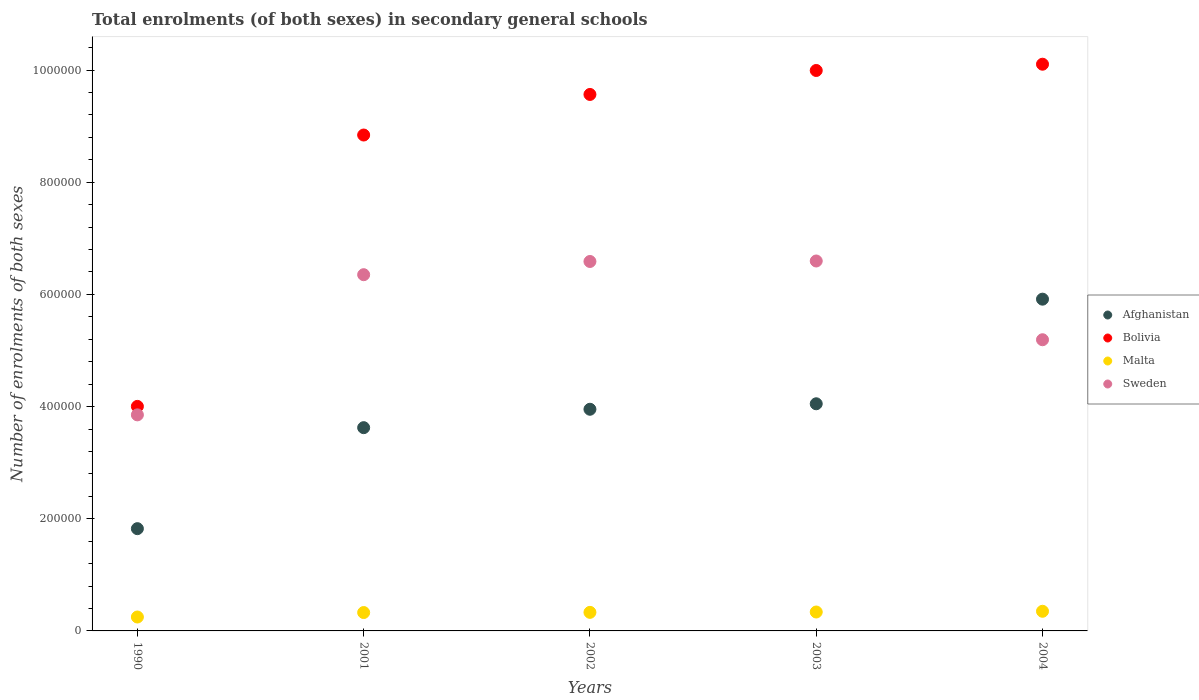Is the number of dotlines equal to the number of legend labels?
Your answer should be compact. Yes. What is the number of enrolments in secondary schools in Malta in 2001?
Your answer should be compact. 3.28e+04. Across all years, what is the maximum number of enrolments in secondary schools in Afghanistan?
Provide a short and direct response. 5.92e+05. Across all years, what is the minimum number of enrolments in secondary schools in Sweden?
Make the answer very short. 3.85e+05. In which year was the number of enrolments in secondary schools in Malta maximum?
Provide a succinct answer. 2004. What is the total number of enrolments in secondary schools in Bolivia in the graph?
Keep it short and to the point. 4.25e+06. What is the difference between the number of enrolments in secondary schools in Sweden in 1990 and that in 2003?
Keep it short and to the point. -2.74e+05. What is the difference between the number of enrolments in secondary schools in Malta in 2002 and the number of enrolments in secondary schools in Bolivia in 2003?
Keep it short and to the point. -9.66e+05. What is the average number of enrolments in secondary schools in Afghanistan per year?
Provide a succinct answer. 3.87e+05. In the year 2002, what is the difference between the number of enrolments in secondary schools in Bolivia and number of enrolments in secondary schools in Afghanistan?
Give a very brief answer. 5.61e+05. What is the ratio of the number of enrolments in secondary schools in Malta in 1990 to that in 2002?
Provide a succinct answer. 0.75. Is the difference between the number of enrolments in secondary schools in Bolivia in 1990 and 2001 greater than the difference between the number of enrolments in secondary schools in Afghanistan in 1990 and 2001?
Keep it short and to the point. No. What is the difference between the highest and the second highest number of enrolments in secondary schools in Sweden?
Your answer should be compact. 878. What is the difference between the highest and the lowest number of enrolments in secondary schools in Sweden?
Give a very brief answer. 2.74e+05. In how many years, is the number of enrolments in secondary schools in Afghanistan greater than the average number of enrolments in secondary schools in Afghanistan taken over all years?
Your response must be concise. 3. Is the sum of the number of enrolments in secondary schools in Bolivia in 2001 and 2004 greater than the maximum number of enrolments in secondary schools in Sweden across all years?
Ensure brevity in your answer.  Yes. Is it the case that in every year, the sum of the number of enrolments in secondary schools in Bolivia and number of enrolments in secondary schools in Afghanistan  is greater than the sum of number of enrolments in secondary schools in Malta and number of enrolments in secondary schools in Sweden?
Offer a very short reply. Yes. Is it the case that in every year, the sum of the number of enrolments in secondary schools in Sweden and number of enrolments in secondary schools in Afghanistan  is greater than the number of enrolments in secondary schools in Bolivia?
Ensure brevity in your answer.  Yes. Does the number of enrolments in secondary schools in Malta monotonically increase over the years?
Your answer should be compact. Yes. What is the difference between two consecutive major ticks on the Y-axis?
Ensure brevity in your answer.  2.00e+05. Are the values on the major ticks of Y-axis written in scientific E-notation?
Your answer should be compact. No. Does the graph contain any zero values?
Offer a very short reply. No. Does the graph contain grids?
Your response must be concise. No. Where does the legend appear in the graph?
Provide a short and direct response. Center right. How many legend labels are there?
Offer a very short reply. 4. What is the title of the graph?
Give a very brief answer. Total enrolments (of both sexes) in secondary general schools. Does "Swaziland" appear as one of the legend labels in the graph?
Offer a terse response. No. What is the label or title of the Y-axis?
Keep it short and to the point. Number of enrolments of both sexes. What is the Number of enrolments of both sexes in Afghanistan in 1990?
Ensure brevity in your answer.  1.82e+05. What is the Number of enrolments of both sexes of Bolivia in 1990?
Your answer should be compact. 4.00e+05. What is the Number of enrolments of both sexes in Malta in 1990?
Keep it short and to the point. 2.48e+04. What is the Number of enrolments of both sexes of Sweden in 1990?
Your response must be concise. 3.85e+05. What is the Number of enrolments of both sexes in Afghanistan in 2001?
Give a very brief answer. 3.62e+05. What is the Number of enrolments of both sexes of Bolivia in 2001?
Ensure brevity in your answer.  8.84e+05. What is the Number of enrolments of both sexes in Malta in 2001?
Provide a short and direct response. 3.28e+04. What is the Number of enrolments of both sexes in Sweden in 2001?
Provide a short and direct response. 6.35e+05. What is the Number of enrolments of both sexes in Afghanistan in 2002?
Your answer should be very brief. 3.95e+05. What is the Number of enrolments of both sexes of Bolivia in 2002?
Ensure brevity in your answer.  9.57e+05. What is the Number of enrolments of both sexes in Malta in 2002?
Your answer should be very brief. 3.31e+04. What is the Number of enrolments of both sexes of Sweden in 2002?
Your response must be concise. 6.59e+05. What is the Number of enrolments of both sexes of Afghanistan in 2003?
Keep it short and to the point. 4.05e+05. What is the Number of enrolments of both sexes in Bolivia in 2003?
Offer a terse response. 9.99e+05. What is the Number of enrolments of both sexes in Malta in 2003?
Give a very brief answer. 3.37e+04. What is the Number of enrolments of both sexes of Sweden in 2003?
Your answer should be compact. 6.60e+05. What is the Number of enrolments of both sexes in Afghanistan in 2004?
Your answer should be compact. 5.92e+05. What is the Number of enrolments of both sexes of Bolivia in 2004?
Your answer should be very brief. 1.01e+06. What is the Number of enrolments of both sexes in Malta in 2004?
Offer a terse response. 3.50e+04. What is the Number of enrolments of both sexes of Sweden in 2004?
Ensure brevity in your answer.  5.19e+05. Across all years, what is the maximum Number of enrolments of both sexes of Afghanistan?
Give a very brief answer. 5.92e+05. Across all years, what is the maximum Number of enrolments of both sexes in Bolivia?
Your answer should be very brief. 1.01e+06. Across all years, what is the maximum Number of enrolments of both sexes in Malta?
Keep it short and to the point. 3.50e+04. Across all years, what is the maximum Number of enrolments of both sexes in Sweden?
Keep it short and to the point. 6.60e+05. Across all years, what is the minimum Number of enrolments of both sexes in Afghanistan?
Ensure brevity in your answer.  1.82e+05. Across all years, what is the minimum Number of enrolments of both sexes of Bolivia?
Ensure brevity in your answer.  4.00e+05. Across all years, what is the minimum Number of enrolments of both sexes of Malta?
Provide a succinct answer. 2.48e+04. Across all years, what is the minimum Number of enrolments of both sexes of Sweden?
Provide a succinct answer. 3.85e+05. What is the total Number of enrolments of both sexes in Afghanistan in the graph?
Make the answer very short. 1.94e+06. What is the total Number of enrolments of both sexes of Bolivia in the graph?
Offer a very short reply. 4.25e+06. What is the total Number of enrolments of both sexes of Malta in the graph?
Your response must be concise. 1.59e+05. What is the total Number of enrolments of both sexes of Sweden in the graph?
Provide a succinct answer. 2.86e+06. What is the difference between the Number of enrolments of both sexes in Afghanistan in 1990 and that in 2001?
Your response must be concise. -1.80e+05. What is the difference between the Number of enrolments of both sexes of Bolivia in 1990 and that in 2001?
Your answer should be very brief. -4.84e+05. What is the difference between the Number of enrolments of both sexes in Malta in 1990 and that in 2001?
Your answer should be very brief. -7968. What is the difference between the Number of enrolments of both sexes in Sweden in 1990 and that in 2001?
Your answer should be compact. -2.50e+05. What is the difference between the Number of enrolments of both sexes of Afghanistan in 1990 and that in 2002?
Give a very brief answer. -2.13e+05. What is the difference between the Number of enrolments of both sexes of Bolivia in 1990 and that in 2002?
Offer a terse response. -5.56e+05. What is the difference between the Number of enrolments of both sexes in Malta in 1990 and that in 2002?
Your response must be concise. -8296. What is the difference between the Number of enrolments of both sexes of Sweden in 1990 and that in 2002?
Your response must be concise. -2.73e+05. What is the difference between the Number of enrolments of both sexes of Afghanistan in 1990 and that in 2003?
Provide a succinct answer. -2.23e+05. What is the difference between the Number of enrolments of both sexes in Bolivia in 1990 and that in 2003?
Offer a very short reply. -5.99e+05. What is the difference between the Number of enrolments of both sexes in Malta in 1990 and that in 2003?
Offer a very short reply. -8929. What is the difference between the Number of enrolments of both sexes in Sweden in 1990 and that in 2003?
Ensure brevity in your answer.  -2.74e+05. What is the difference between the Number of enrolments of both sexes in Afghanistan in 1990 and that in 2004?
Offer a very short reply. -4.09e+05. What is the difference between the Number of enrolments of both sexes in Bolivia in 1990 and that in 2004?
Give a very brief answer. -6.10e+05. What is the difference between the Number of enrolments of both sexes of Malta in 1990 and that in 2004?
Offer a very short reply. -1.02e+04. What is the difference between the Number of enrolments of both sexes of Sweden in 1990 and that in 2004?
Offer a very short reply. -1.34e+05. What is the difference between the Number of enrolments of both sexes of Afghanistan in 2001 and that in 2002?
Ensure brevity in your answer.  -3.28e+04. What is the difference between the Number of enrolments of both sexes of Bolivia in 2001 and that in 2002?
Offer a terse response. -7.23e+04. What is the difference between the Number of enrolments of both sexes of Malta in 2001 and that in 2002?
Provide a succinct answer. -328. What is the difference between the Number of enrolments of both sexes of Sweden in 2001 and that in 2002?
Keep it short and to the point. -2.36e+04. What is the difference between the Number of enrolments of both sexes in Afghanistan in 2001 and that in 2003?
Offer a terse response. -4.26e+04. What is the difference between the Number of enrolments of both sexes of Bolivia in 2001 and that in 2003?
Provide a succinct answer. -1.15e+05. What is the difference between the Number of enrolments of both sexes of Malta in 2001 and that in 2003?
Keep it short and to the point. -961. What is the difference between the Number of enrolments of both sexes in Sweden in 2001 and that in 2003?
Offer a very short reply. -2.44e+04. What is the difference between the Number of enrolments of both sexes of Afghanistan in 2001 and that in 2004?
Offer a terse response. -2.29e+05. What is the difference between the Number of enrolments of both sexes of Bolivia in 2001 and that in 2004?
Your response must be concise. -1.26e+05. What is the difference between the Number of enrolments of both sexes of Malta in 2001 and that in 2004?
Provide a succinct answer. -2251. What is the difference between the Number of enrolments of both sexes of Sweden in 2001 and that in 2004?
Offer a terse response. 1.16e+05. What is the difference between the Number of enrolments of both sexes in Afghanistan in 2002 and that in 2003?
Your answer should be compact. -9779. What is the difference between the Number of enrolments of both sexes in Bolivia in 2002 and that in 2003?
Your answer should be compact. -4.27e+04. What is the difference between the Number of enrolments of both sexes in Malta in 2002 and that in 2003?
Offer a terse response. -633. What is the difference between the Number of enrolments of both sexes of Sweden in 2002 and that in 2003?
Your answer should be very brief. -878. What is the difference between the Number of enrolments of both sexes of Afghanistan in 2002 and that in 2004?
Provide a short and direct response. -1.96e+05. What is the difference between the Number of enrolments of both sexes in Bolivia in 2002 and that in 2004?
Your answer should be very brief. -5.39e+04. What is the difference between the Number of enrolments of both sexes of Malta in 2002 and that in 2004?
Make the answer very short. -1923. What is the difference between the Number of enrolments of both sexes in Sweden in 2002 and that in 2004?
Provide a succinct answer. 1.40e+05. What is the difference between the Number of enrolments of both sexes in Afghanistan in 2003 and that in 2004?
Give a very brief answer. -1.87e+05. What is the difference between the Number of enrolments of both sexes of Bolivia in 2003 and that in 2004?
Offer a very short reply. -1.12e+04. What is the difference between the Number of enrolments of both sexes of Malta in 2003 and that in 2004?
Your answer should be very brief. -1290. What is the difference between the Number of enrolments of both sexes in Sweden in 2003 and that in 2004?
Provide a succinct answer. 1.40e+05. What is the difference between the Number of enrolments of both sexes in Afghanistan in 1990 and the Number of enrolments of both sexes in Bolivia in 2001?
Your response must be concise. -7.02e+05. What is the difference between the Number of enrolments of both sexes in Afghanistan in 1990 and the Number of enrolments of both sexes in Malta in 2001?
Offer a terse response. 1.50e+05. What is the difference between the Number of enrolments of both sexes of Afghanistan in 1990 and the Number of enrolments of both sexes of Sweden in 2001?
Provide a short and direct response. -4.53e+05. What is the difference between the Number of enrolments of both sexes of Bolivia in 1990 and the Number of enrolments of both sexes of Malta in 2001?
Offer a very short reply. 3.68e+05. What is the difference between the Number of enrolments of both sexes in Bolivia in 1990 and the Number of enrolments of both sexes in Sweden in 2001?
Give a very brief answer. -2.35e+05. What is the difference between the Number of enrolments of both sexes in Malta in 1990 and the Number of enrolments of both sexes in Sweden in 2001?
Your answer should be very brief. -6.10e+05. What is the difference between the Number of enrolments of both sexes in Afghanistan in 1990 and the Number of enrolments of both sexes in Bolivia in 2002?
Give a very brief answer. -7.74e+05. What is the difference between the Number of enrolments of both sexes of Afghanistan in 1990 and the Number of enrolments of both sexes of Malta in 2002?
Provide a short and direct response. 1.49e+05. What is the difference between the Number of enrolments of both sexes in Afghanistan in 1990 and the Number of enrolments of both sexes in Sweden in 2002?
Give a very brief answer. -4.76e+05. What is the difference between the Number of enrolments of both sexes in Bolivia in 1990 and the Number of enrolments of both sexes in Malta in 2002?
Give a very brief answer. 3.67e+05. What is the difference between the Number of enrolments of both sexes in Bolivia in 1990 and the Number of enrolments of both sexes in Sweden in 2002?
Give a very brief answer. -2.58e+05. What is the difference between the Number of enrolments of both sexes of Malta in 1990 and the Number of enrolments of both sexes of Sweden in 2002?
Give a very brief answer. -6.34e+05. What is the difference between the Number of enrolments of both sexes in Afghanistan in 1990 and the Number of enrolments of both sexes in Bolivia in 2003?
Ensure brevity in your answer.  -8.17e+05. What is the difference between the Number of enrolments of both sexes in Afghanistan in 1990 and the Number of enrolments of both sexes in Malta in 2003?
Your response must be concise. 1.49e+05. What is the difference between the Number of enrolments of both sexes in Afghanistan in 1990 and the Number of enrolments of both sexes in Sweden in 2003?
Offer a very short reply. -4.77e+05. What is the difference between the Number of enrolments of both sexes in Bolivia in 1990 and the Number of enrolments of both sexes in Malta in 2003?
Offer a terse response. 3.67e+05. What is the difference between the Number of enrolments of both sexes of Bolivia in 1990 and the Number of enrolments of both sexes of Sweden in 2003?
Provide a succinct answer. -2.59e+05. What is the difference between the Number of enrolments of both sexes in Malta in 1990 and the Number of enrolments of both sexes in Sweden in 2003?
Provide a succinct answer. -6.35e+05. What is the difference between the Number of enrolments of both sexes of Afghanistan in 1990 and the Number of enrolments of both sexes of Bolivia in 2004?
Your response must be concise. -8.28e+05. What is the difference between the Number of enrolments of both sexes in Afghanistan in 1990 and the Number of enrolments of both sexes in Malta in 2004?
Keep it short and to the point. 1.47e+05. What is the difference between the Number of enrolments of both sexes of Afghanistan in 1990 and the Number of enrolments of both sexes of Sweden in 2004?
Provide a short and direct response. -3.37e+05. What is the difference between the Number of enrolments of both sexes of Bolivia in 1990 and the Number of enrolments of both sexes of Malta in 2004?
Offer a very short reply. 3.65e+05. What is the difference between the Number of enrolments of both sexes in Bolivia in 1990 and the Number of enrolments of both sexes in Sweden in 2004?
Provide a short and direct response. -1.19e+05. What is the difference between the Number of enrolments of both sexes in Malta in 1990 and the Number of enrolments of both sexes in Sweden in 2004?
Your answer should be compact. -4.94e+05. What is the difference between the Number of enrolments of both sexes of Afghanistan in 2001 and the Number of enrolments of both sexes of Bolivia in 2002?
Keep it short and to the point. -5.94e+05. What is the difference between the Number of enrolments of both sexes of Afghanistan in 2001 and the Number of enrolments of both sexes of Malta in 2002?
Your response must be concise. 3.29e+05. What is the difference between the Number of enrolments of both sexes of Afghanistan in 2001 and the Number of enrolments of both sexes of Sweden in 2002?
Provide a short and direct response. -2.96e+05. What is the difference between the Number of enrolments of both sexes of Bolivia in 2001 and the Number of enrolments of both sexes of Malta in 2002?
Give a very brief answer. 8.51e+05. What is the difference between the Number of enrolments of both sexes in Bolivia in 2001 and the Number of enrolments of both sexes in Sweden in 2002?
Make the answer very short. 2.25e+05. What is the difference between the Number of enrolments of both sexes in Malta in 2001 and the Number of enrolments of both sexes in Sweden in 2002?
Ensure brevity in your answer.  -6.26e+05. What is the difference between the Number of enrolments of both sexes of Afghanistan in 2001 and the Number of enrolments of both sexes of Bolivia in 2003?
Your response must be concise. -6.37e+05. What is the difference between the Number of enrolments of both sexes in Afghanistan in 2001 and the Number of enrolments of both sexes in Malta in 2003?
Give a very brief answer. 3.29e+05. What is the difference between the Number of enrolments of both sexes in Afghanistan in 2001 and the Number of enrolments of both sexes in Sweden in 2003?
Offer a very short reply. -2.97e+05. What is the difference between the Number of enrolments of both sexes of Bolivia in 2001 and the Number of enrolments of both sexes of Malta in 2003?
Your answer should be compact. 8.50e+05. What is the difference between the Number of enrolments of both sexes of Bolivia in 2001 and the Number of enrolments of both sexes of Sweden in 2003?
Your response must be concise. 2.25e+05. What is the difference between the Number of enrolments of both sexes of Malta in 2001 and the Number of enrolments of both sexes of Sweden in 2003?
Your answer should be very brief. -6.27e+05. What is the difference between the Number of enrolments of both sexes of Afghanistan in 2001 and the Number of enrolments of both sexes of Bolivia in 2004?
Offer a terse response. -6.48e+05. What is the difference between the Number of enrolments of both sexes in Afghanistan in 2001 and the Number of enrolments of both sexes in Malta in 2004?
Keep it short and to the point. 3.27e+05. What is the difference between the Number of enrolments of both sexes of Afghanistan in 2001 and the Number of enrolments of both sexes of Sweden in 2004?
Your answer should be very brief. -1.57e+05. What is the difference between the Number of enrolments of both sexes of Bolivia in 2001 and the Number of enrolments of both sexes of Malta in 2004?
Give a very brief answer. 8.49e+05. What is the difference between the Number of enrolments of both sexes in Bolivia in 2001 and the Number of enrolments of both sexes in Sweden in 2004?
Offer a very short reply. 3.65e+05. What is the difference between the Number of enrolments of both sexes of Malta in 2001 and the Number of enrolments of both sexes of Sweden in 2004?
Offer a terse response. -4.86e+05. What is the difference between the Number of enrolments of both sexes of Afghanistan in 2002 and the Number of enrolments of both sexes of Bolivia in 2003?
Give a very brief answer. -6.04e+05. What is the difference between the Number of enrolments of both sexes in Afghanistan in 2002 and the Number of enrolments of both sexes in Malta in 2003?
Give a very brief answer. 3.61e+05. What is the difference between the Number of enrolments of both sexes in Afghanistan in 2002 and the Number of enrolments of both sexes in Sweden in 2003?
Provide a short and direct response. -2.64e+05. What is the difference between the Number of enrolments of both sexes of Bolivia in 2002 and the Number of enrolments of both sexes of Malta in 2003?
Ensure brevity in your answer.  9.23e+05. What is the difference between the Number of enrolments of both sexes in Bolivia in 2002 and the Number of enrolments of both sexes in Sweden in 2003?
Your response must be concise. 2.97e+05. What is the difference between the Number of enrolments of both sexes in Malta in 2002 and the Number of enrolments of both sexes in Sweden in 2003?
Ensure brevity in your answer.  -6.27e+05. What is the difference between the Number of enrolments of both sexes of Afghanistan in 2002 and the Number of enrolments of both sexes of Bolivia in 2004?
Offer a very short reply. -6.15e+05. What is the difference between the Number of enrolments of both sexes in Afghanistan in 2002 and the Number of enrolments of both sexes in Malta in 2004?
Make the answer very short. 3.60e+05. What is the difference between the Number of enrolments of both sexes of Afghanistan in 2002 and the Number of enrolments of both sexes of Sweden in 2004?
Your answer should be compact. -1.24e+05. What is the difference between the Number of enrolments of both sexes of Bolivia in 2002 and the Number of enrolments of both sexes of Malta in 2004?
Provide a short and direct response. 9.22e+05. What is the difference between the Number of enrolments of both sexes of Bolivia in 2002 and the Number of enrolments of both sexes of Sweden in 2004?
Offer a very short reply. 4.37e+05. What is the difference between the Number of enrolments of both sexes in Malta in 2002 and the Number of enrolments of both sexes in Sweden in 2004?
Make the answer very short. -4.86e+05. What is the difference between the Number of enrolments of both sexes in Afghanistan in 2003 and the Number of enrolments of both sexes in Bolivia in 2004?
Your answer should be compact. -6.05e+05. What is the difference between the Number of enrolments of both sexes in Afghanistan in 2003 and the Number of enrolments of both sexes in Malta in 2004?
Your answer should be compact. 3.70e+05. What is the difference between the Number of enrolments of both sexes in Afghanistan in 2003 and the Number of enrolments of both sexes in Sweden in 2004?
Give a very brief answer. -1.14e+05. What is the difference between the Number of enrolments of both sexes in Bolivia in 2003 and the Number of enrolments of both sexes in Malta in 2004?
Your answer should be compact. 9.64e+05. What is the difference between the Number of enrolments of both sexes of Bolivia in 2003 and the Number of enrolments of both sexes of Sweden in 2004?
Offer a terse response. 4.80e+05. What is the difference between the Number of enrolments of both sexes in Malta in 2003 and the Number of enrolments of both sexes in Sweden in 2004?
Provide a succinct answer. -4.85e+05. What is the average Number of enrolments of both sexes in Afghanistan per year?
Offer a terse response. 3.87e+05. What is the average Number of enrolments of both sexes of Bolivia per year?
Provide a succinct answer. 8.50e+05. What is the average Number of enrolments of both sexes of Malta per year?
Make the answer very short. 3.19e+04. What is the average Number of enrolments of both sexes in Sweden per year?
Your answer should be compact. 5.72e+05. In the year 1990, what is the difference between the Number of enrolments of both sexes of Afghanistan and Number of enrolments of both sexes of Bolivia?
Offer a terse response. -2.18e+05. In the year 1990, what is the difference between the Number of enrolments of both sexes in Afghanistan and Number of enrolments of both sexes in Malta?
Offer a very short reply. 1.58e+05. In the year 1990, what is the difference between the Number of enrolments of both sexes in Afghanistan and Number of enrolments of both sexes in Sweden?
Your answer should be compact. -2.03e+05. In the year 1990, what is the difference between the Number of enrolments of both sexes in Bolivia and Number of enrolments of both sexes in Malta?
Keep it short and to the point. 3.76e+05. In the year 1990, what is the difference between the Number of enrolments of both sexes of Bolivia and Number of enrolments of both sexes of Sweden?
Your answer should be very brief. 1.51e+04. In the year 1990, what is the difference between the Number of enrolments of both sexes in Malta and Number of enrolments of both sexes in Sweden?
Your answer should be very brief. -3.60e+05. In the year 2001, what is the difference between the Number of enrolments of both sexes in Afghanistan and Number of enrolments of both sexes in Bolivia?
Provide a succinct answer. -5.22e+05. In the year 2001, what is the difference between the Number of enrolments of both sexes in Afghanistan and Number of enrolments of both sexes in Malta?
Keep it short and to the point. 3.30e+05. In the year 2001, what is the difference between the Number of enrolments of both sexes of Afghanistan and Number of enrolments of both sexes of Sweden?
Keep it short and to the point. -2.73e+05. In the year 2001, what is the difference between the Number of enrolments of both sexes in Bolivia and Number of enrolments of both sexes in Malta?
Keep it short and to the point. 8.51e+05. In the year 2001, what is the difference between the Number of enrolments of both sexes of Bolivia and Number of enrolments of both sexes of Sweden?
Make the answer very short. 2.49e+05. In the year 2001, what is the difference between the Number of enrolments of both sexes of Malta and Number of enrolments of both sexes of Sweden?
Provide a short and direct response. -6.02e+05. In the year 2002, what is the difference between the Number of enrolments of both sexes in Afghanistan and Number of enrolments of both sexes in Bolivia?
Keep it short and to the point. -5.61e+05. In the year 2002, what is the difference between the Number of enrolments of both sexes in Afghanistan and Number of enrolments of both sexes in Malta?
Make the answer very short. 3.62e+05. In the year 2002, what is the difference between the Number of enrolments of both sexes in Afghanistan and Number of enrolments of both sexes in Sweden?
Your answer should be compact. -2.63e+05. In the year 2002, what is the difference between the Number of enrolments of both sexes in Bolivia and Number of enrolments of both sexes in Malta?
Provide a succinct answer. 9.23e+05. In the year 2002, what is the difference between the Number of enrolments of both sexes of Bolivia and Number of enrolments of both sexes of Sweden?
Ensure brevity in your answer.  2.98e+05. In the year 2002, what is the difference between the Number of enrolments of both sexes in Malta and Number of enrolments of both sexes in Sweden?
Ensure brevity in your answer.  -6.26e+05. In the year 2003, what is the difference between the Number of enrolments of both sexes in Afghanistan and Number of enrolments of both sexes in Bolivia?
Offer a terse response. -5.94e+05. In the year 2003, what is the difference between the Number of enrolments of both sexes in Afghanistan and Number of enrolments of both sexes in Malta?
Keep it short and to the point. 3.71e+05. In the year 2003, what is the difference between the Number of enrolments of both sexes in Afghanistan and Number of enrolments of both sexes in Sweden?
Provide a short and direct response. -2.55e+05. In the year 2003, what is the difference between the Number of enrolments of both sexes in Bolivia and Number of enrolments of both sexes in Malta?
Your answer should be very brief. 9.66e+05. In the year 2003, what is the difference between the Number of enrolments of both sexes of Bolivia and Number of enrolments of both sexes of Sweden?
Give a very brief answer. 3.40e+05. In the year 2003, what is the difference between the Number of enrolments of both sexes of Malta and Number of enrolments of both sexes of Sweden?
Your response must be concise. -6.26e+05. In the year 2004, what is the difference between the Number of enrolments of both sexes of Afghanistan and Number of enrolments of both sexes of Bolivia?
Give a very brief answer. -4.19e+05. In the year 2004, what is the difference between the Number of enrolments of both sexes in Afghanistan and Number of enrolments of both sexes in Malta?
Offer a terse response. 5.57e+05. In the year 2004, what is the difference between the Number of enrolments of both sexes in Afghanistan and Number of enrolments of both sexes in Sweden?
Provide a succinct answer. 7.24e+04. In the year 2004, what is the difference between the Number of enrolments of both sexes in Bolivia and Number of enrolments of both sexes in Malta?
Keep it short and to the point. 9.75e+05. In the year 2004, what is the difference between the Number of enrolments of both sexes of Bolivia and Number of enrolments of both sexes of Sweden?
Your response must be concise. 4.91e+05. In the year 2004, what is the difference between the Number of enrolments of both sexes of Malta and Number of enrolments of both sexes of Sweden?
Make the answer very short. -4.84e+05. What is the ratio of the Number of enrolments of both sexes of Afghanistan in 1990 to that in 2001?
Keep it short and to the point. 0.5. What is the ratio of the Number of enrolments of both sexes in Bolivia in 1990 to that in 2001?
Your response must be concise. 0.45. What is the ratio of the Number of enrolments of both sexes in Malta in 1990 to that in 2001?
Your answer should be very brief. 0.76. What is the ratio of the Number of enrolments of both sexes in Sweden in 1990 to that in 2001?
Ensure brevity in your answer.  0.61. What is the ratio of the Number of enrolments of both sexes of Afghanistan in 1990 to that in 2002?
Keep it short and to the point. 0.46. What is the ratio of the Number of enrolments of both sexes of Bolivia in 1990 to that in 2002?
Provide a succinct answer. 0.42. What is the ratio of the Number of enrolments of both sexes of Malta in 1990 to that in 2002?
Keep it short and to the point. 0.75. What is the ratio of the Number of enrolments of both sexes in Sweden in 1990 to that in 2002?
Make the answer very short. 0.58. What is the ratio of the Number of enrolments of both sexes of Afghanistan in 1990 to that in 2003?
Provide a short and direct response. 0.45. What is the ratio of the Number of enrolments of both sexes of Bolivia in 1990 to that in 2003?
Give a very brief answer. 0.4. What is the ratio of the Number of enrolments of both sexes of Malta in 1990 to that in 2003?
Offer a very short reply. 0.74. What is the ratio of the Number of enrolments of both sexes of Sweden in 1990 to that in 2003?
Provide a short and direct response. 0.58. What is the ratio of the Number of enrolments of both sexes in Afghanistan in 1990 to that in 2004?
Ensure brevity in your answer.  0.31. What is the ratio of the Number of enrolments of both sexes in Bolivia in 1990 to that in 2004?
Offer a very short reply. 0.4. What is the ratio of the Number of enrolments of both sexes of Malta in 1990 to that in 2004?
Give a very brief answer. 0.71. What is the ratio of the Number of enrolments of both sexes of Sweden in 1990 to that in 2004?
Give a very brief answer. 0.74. What is the ratio of the Number of enrolments of both sexes in Afghanistan in 2001 to that in 2002?
Ensure brevity in your answer.  0.92. What is the ratio of the Number of enrolments of both sexes in Bolivia in 2001 to that in 2002?
Make the answer very short. 0.92. What is the ratio of the Number of enrolments of both sexes in Sweden in 2001 to that in 2002?
Your response must be concise. 0.96. What is the ratio of the Number of enrolments of both sexes in Afghanistan in 2001 to that in 2003?
Ensure brevity in your answer.  0.89. What is the ratio of the Number of enrolments of both sexes in Bolivia in 2001 to that in 2003?
Your answer should be compact. 0.88. What is the ratio of the Number of enrolments of both sexes of Malta in 2001 to that in 2003?
Provide a succinct answer. 0.97. What is the ratio of the Number of enrolments of both sexes in Sweden in 2001 to that in 2003?
Offer a very short reply. 0.96. What is the ratio of the Number of enrolments of both sexes of Afghanistan in 2001 to that in 2004?
Offer a very short reply. 0.61. What is the ratio of the Number of enrolments of both sexes of Bolivia in 2001 to that in 2004?
Give a very brief answer. 0.88. What is the ratio of the Number of enrolments of both sexes in Malta in 2001 to that in 2004?
Your answer should be very brief. 0.94. What is the ratio of the Number of enrolments of both sexes of Sweden in 2001 to that in 2004?
Your response must be concise. 1.22. What is the ratio of the Number of enrolments of both sexes of Afghanistan in 2002 to that in 2003?
Give a very brief answer. 0.98. What is the ratio of the Number of enrolments of both sexes in Bolivia in 2002 to that in 2003?
Your answer should be very brief. 0.96. What is the ratio of the Number of enrolments of both sexes of Malta in 2002 to that in 2003?
Your answer should be very brief. 0.98. What is the ratio of the Number of enrolments of both sexes in Afghanistan in 2002 to that in 2004?
Make the answer very short. 0.67. What is the ratio of the Number of enrolments of both sexes of Bolivia in 2002 to that in 2004?
Keep it short and to the point. 0.95. What is the ratio of the Number of enrolments of both sexes in Malta in 2002 to that in 2004?
Offer a terse response. 0.95. What is the ratio of the Number of enrolments of both sexes of Sweden in 2002 to that in 2004?
Your response must be concise. 1.27. What is the ratio of the Number of enrolments of both sexes of Afghanistan in 2003 to that in 2004?
Your response must be concise. 0.68. What is the ratio of the Number of enrolments of both sexes of Bolivia in 2003 to that in 2004?
Your answer should be compact. 0.99. What is the ratio of the Number of enrolments of both sexes of Malta in 2003 to that in 2004?
Ensure brevity in your answer.  0.96. What is the ratio of the Number of enrolments of both sexes in Sweden in 2003 to that in 2004?
Make the answer very short. 1.27. What is the difference between the highest and the second highest Number of enrolments of both sexes of Afghanistan?
Keep it short and to the point. 1.87e+05. What is the difference between the highest and the second highest Number of enrolments of both sexes in Bolivia?
Make the answer very short. 1.12e+04. What is the difference between the highest and the second highest Number of enrolments of both sexes in Malta?
Your answer should be compact. 1290. What is the difference between the highest and the second highest Number of enrolments of both sexes of Sweden?
Offer a terse response. 878. What is the difference between the highest and the lowest Number of enrolments of both sexes in Afghanistan?
Provide a short and direct response. 4.09e+05. What is the difference between the highest and the lowest Number of enrolments of both sexes in Bolivia?
Provide a short and direct response. 6.10e+05. What is the difference between the highest and the lowest Number of enrolments of both sexes in Malta?
Offer a very short reply. 1.02e+04. What is the difference between the highest and the lowest Number of enrolments of both sexes of Sweden?
Offer a very short reply. 2.74e+05. 